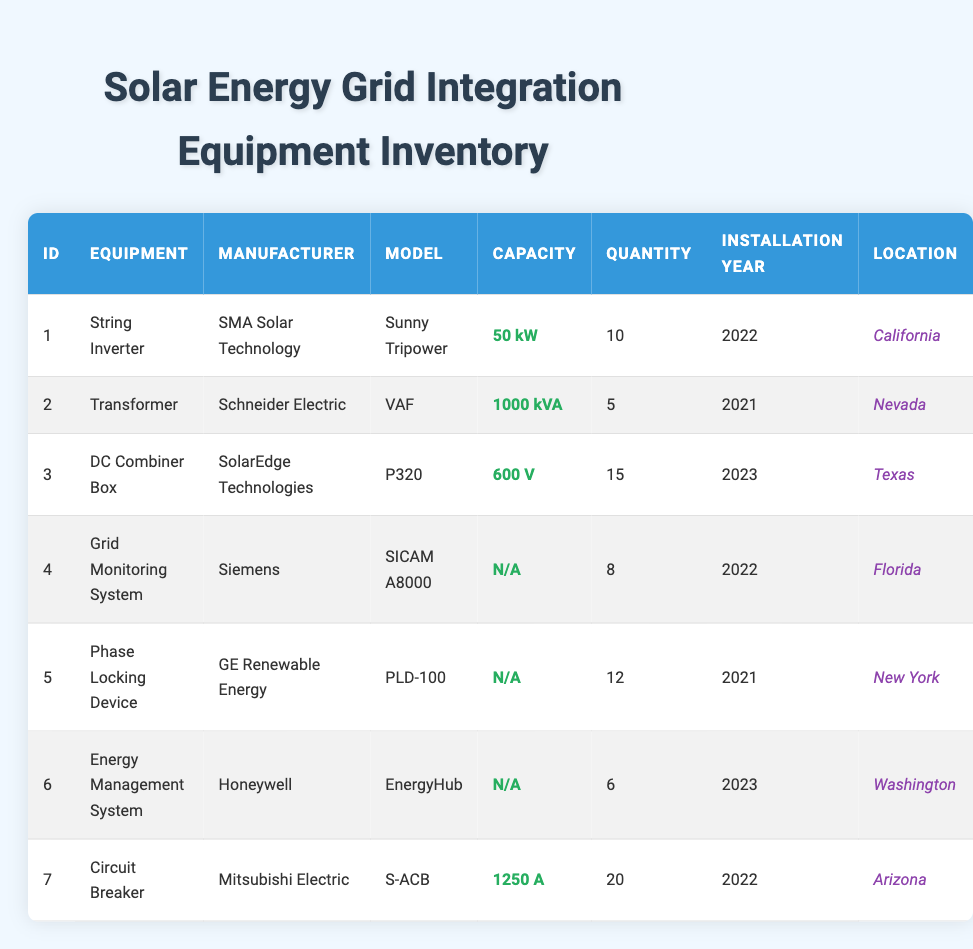What is the total quantity of String Inverters in the inventory? The quantity of String Inverters listed in the table under equipment name is 10.
Answer: 10 How many different types of equipment have been installed in Texas? The only type of equipment installed in Texas according to the table is the DC Combiner Box, and it is the only entry corresponding to Texas.
Answer: 1 What is the capacity of the Circuit Breaker? The capacity of the Circuit Breaker listed in the table is 1250 A.
Answer: 1250 A Is there an Energy Management System located in Florida? The table confirms that there is an Energy Management System, but it is located in Washington, not Florida.
Answer: No How many pieces of equipment have a quantity greater than 10? By checking the table, there are three pieces of equipment with a quantity greater than 10: DC Combiner Box (15), Circuit Breaker (20), and Phase Locking Device (12). The total count is 3.
Answer: 3 What is the average installation year of the equipment? The equipment installation years are 2021 (2 items), 2022 (4 items), and 2023 (2 items). Calculating the average: (2021*2 + 2022*4 + 2023*2) / 8 = (4042) / 8 = 2022.75, which rounds to 2023.
Answer: 2023 Which manufacturer has the highest quantity of equipment and what is that quantity? By comparing quantities from the table, the highest quantity is 20 for the Circuit Breaker from Mitsubishi Electric.
Answer: 20 How many equipment entries are installed in each state? From the inventory: California (1), Nevada (1), Texas (1), Florida (1), New York (1), Washington (1), Arizona (1). Each state has 1 entry, making a total of 7 equipment entries across 7 different states.
Answer: 1 per state (total 7) 